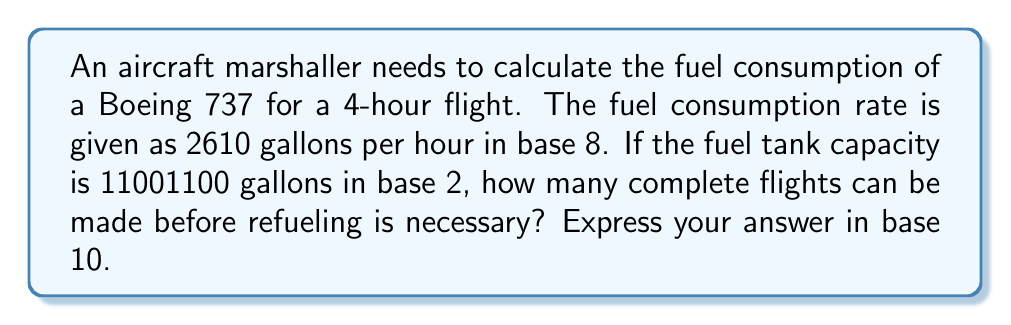What is the answer to this math problem? To solve this problem, we need to follow these steps:

1. Convert the fuel consumption rate from base 8 to base 10:
   $2610_8 = 2 \times 8^3 + 6 \times 8^2 + 1 \times 8^1 + 0 \times 8^0 = 1024 + 384 + 8 + 0 = 1416_{10}$ gallons per hour

2. Calculate the total fuel consumption for a 4-hour flight:
   $1416_{10} \times 4 = 5664_{10}$ gallons

3. Convert the fuel tank capacity from base 2 to base 10:
   $11001100_2 = 1 \times 2^7 + 1 \times 2^6 + 0 \times 2^5 + 0 \times 2^4 + 1 \times 2^3 + 1 \times 2^2 + 0 \times 2^1 + 0 \times 2^0$
   $= 128 + 64 + 0 + 0 + 8 + 4 + 0 + 0 = 204_{10}$ gallons

4. Calculate the number of complete flights:
   $\text{Number of flights} = \left\lfloor\frac{\text{Fuel tank capacity}}{\text{Fuel consumption per flight}}\right\rfloor$
   
   $= \left\lfloor\frac{204_{10}}{5664_{10}}\right\rfloor = \left\lfloor0.036\right\rfloor = 0_{10}$

Therefore, 0 complete flights can be made before refueling is necessary.
Answer: $0_{10}$ 